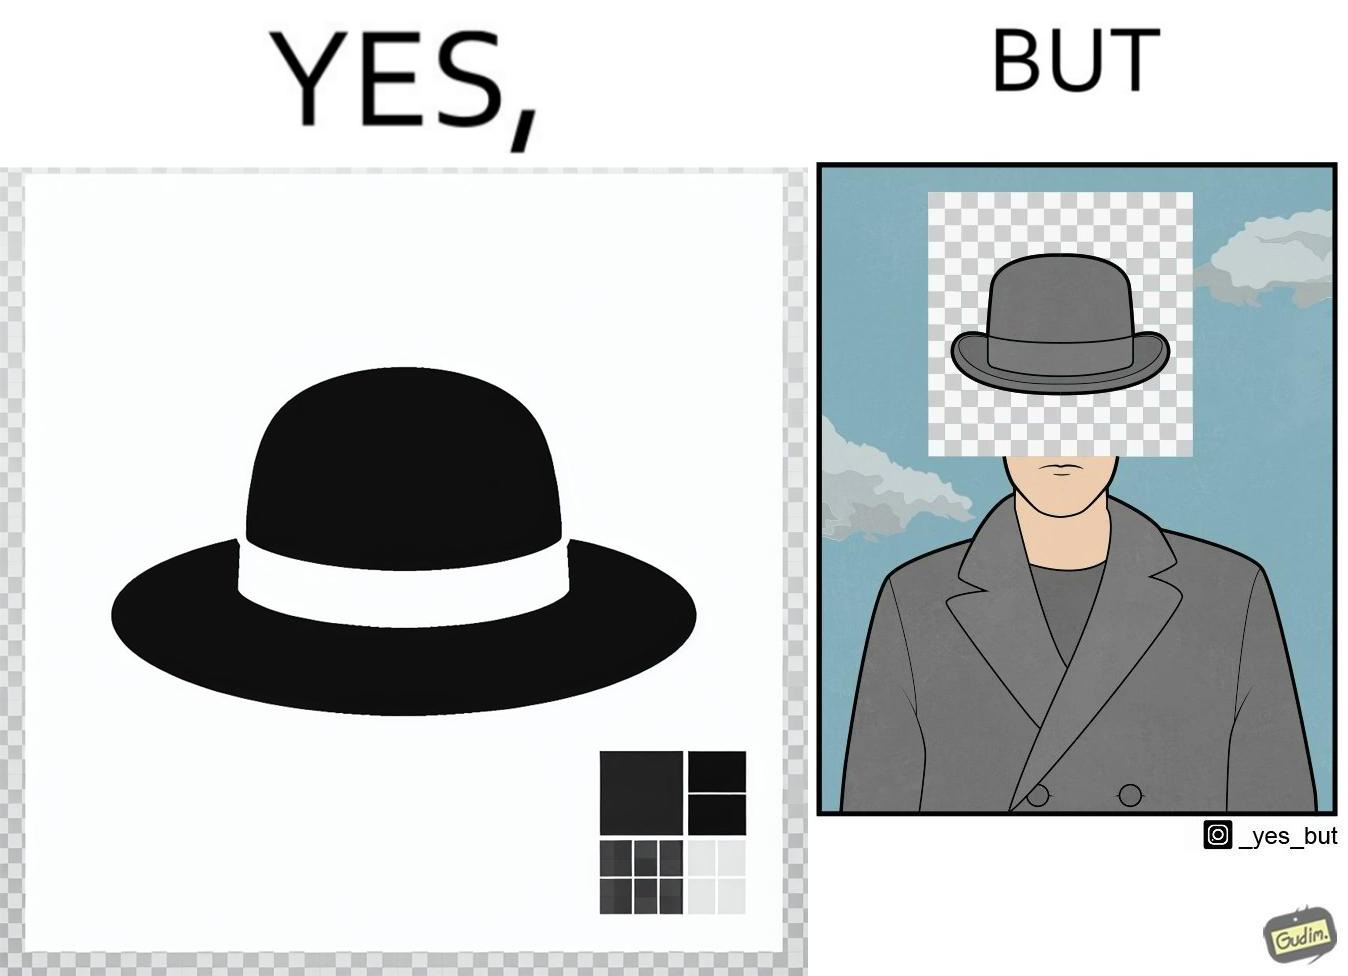Is there satirical content in this image? Yes, this image is satirical. 